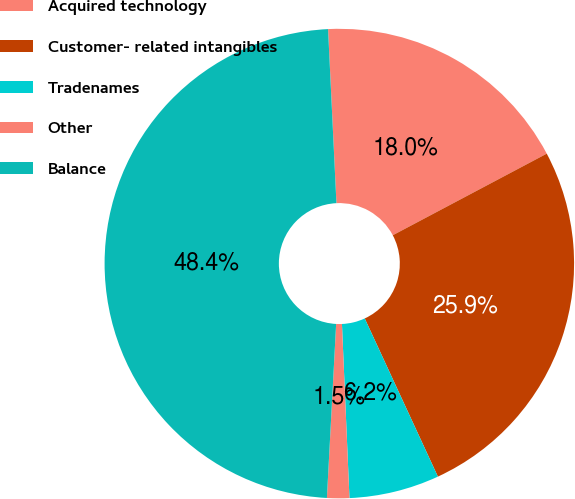<chart> <loc_0><loc_0><loc_500><loc_500><pie_chart><fcel>Acquired technology<fcel>Customer- related intangibles<fcel>Tradenames<fcel>Other<fcel>Balance<nl><fcel>18.01%<fcel>25.86%<fcel>6.21%<fcel>1.53%<fcel>48.39%<nl></chart> 